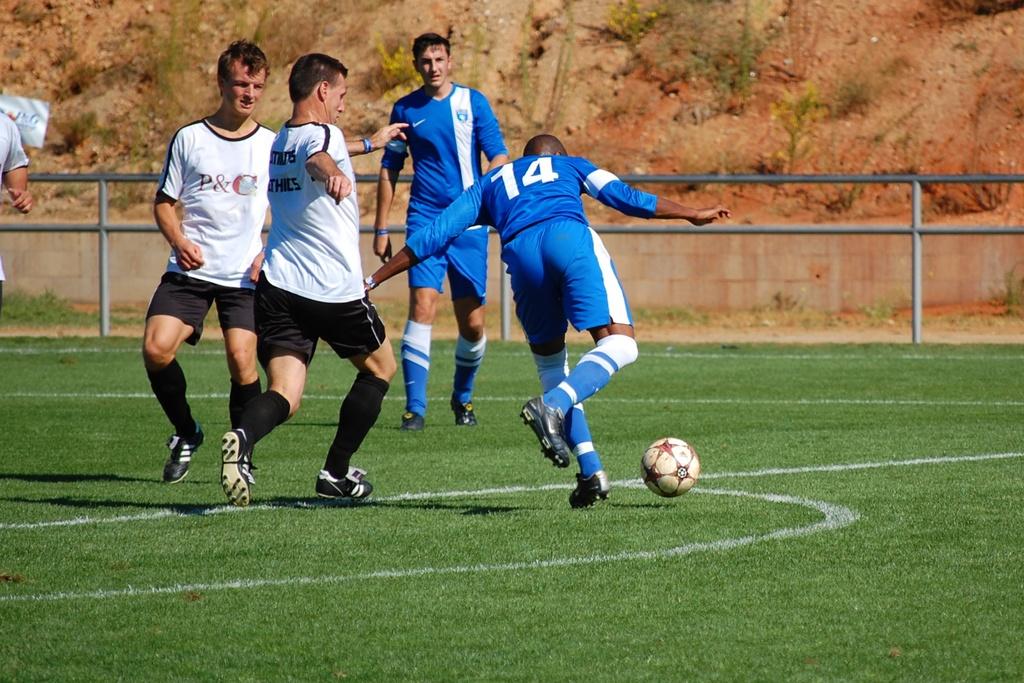What is the number on the blue jersey?
Provide a succinct answer. 14. What does it say on the shirt of the guy in white on the left?
Make the answer very short. P&c. 